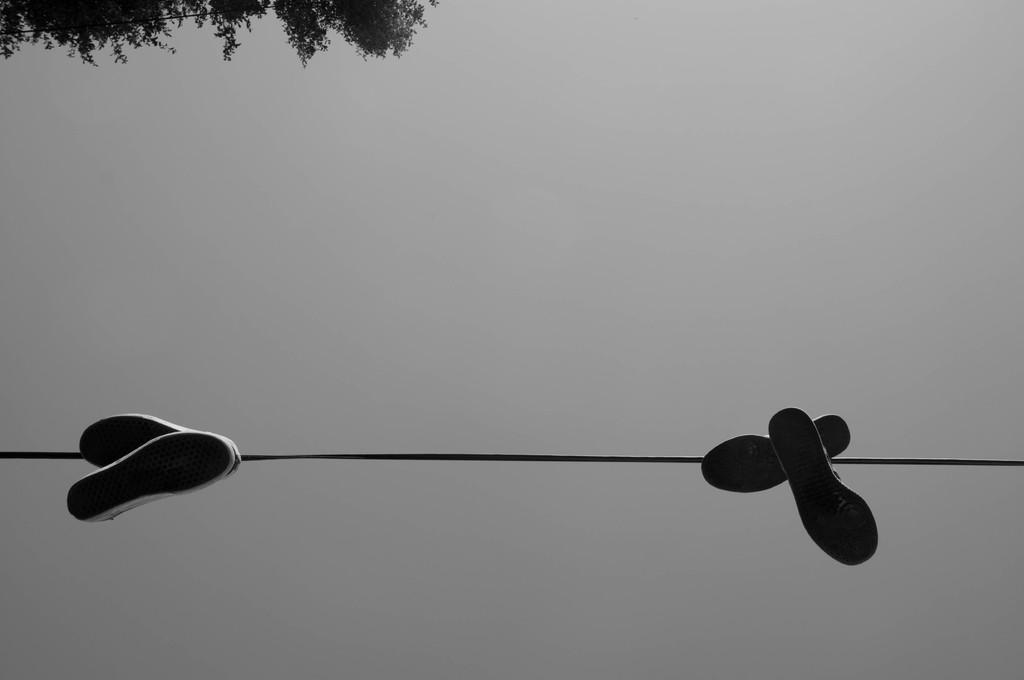How many pairs of shoes are in the image? There are two pairs of shoes in the image. What is the condition of the shoes in the image? The shoes are tied to a rope. What can be seen in the background of the image? There is a plane sky and trees visible in the background. What type of slope can be seen in the image? There is no slope present in the image; it features two pairs of shoes tied to a rope against a background of trees and a plane sky. 